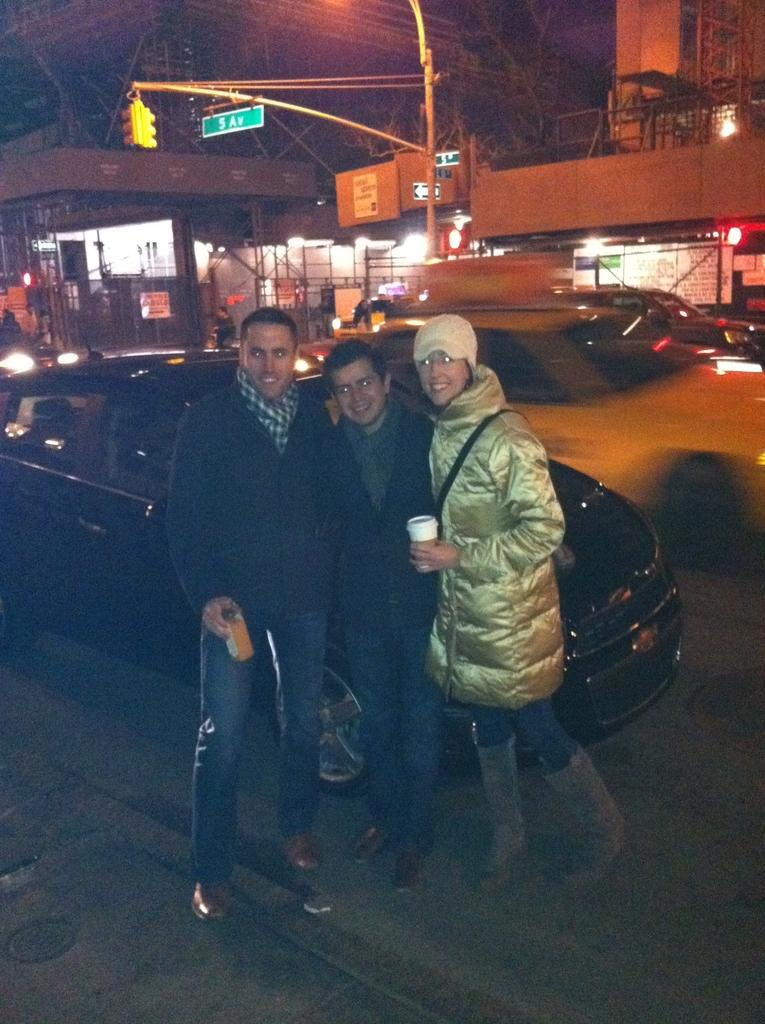How many people are standing in the image? There are three members standing on the ground in the image. What can be seen on the road in the background? There is a black color car on the road in the background. What is visible in the background besides the car? There is a pole and buildings visible in the background. Is there a hill visible in the image? There is no hill present in the image; it features a flat ground with buildings and a car in the background. 